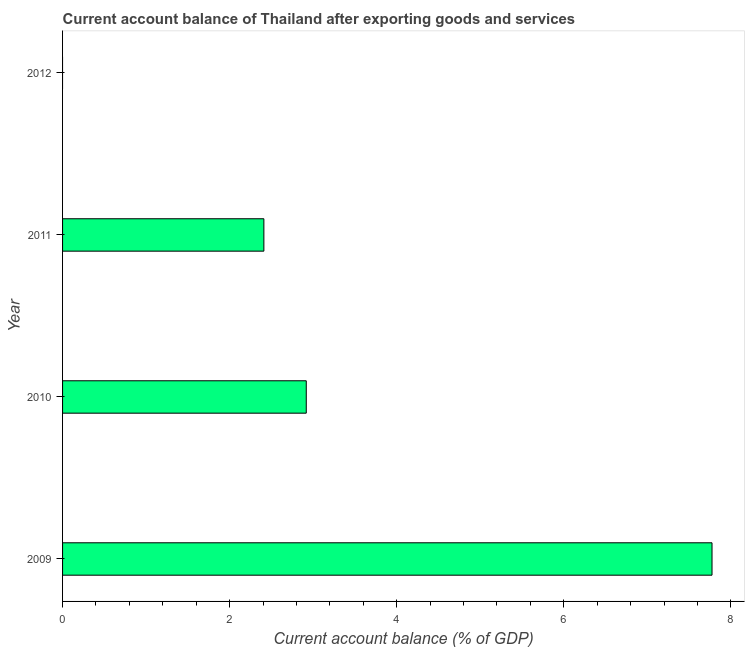Does the graph contain any zero values?
Offer a very short reply. Yes. Does the graph contain grids?
Give a very brief answer. No. What is the title of the graph?
Give a very brief answer. Current account balance of Thailand after exporting goods and services. What is the label or title of the X-axis?
Give a very brief answer. Current account balance (% of GDP). What is the label or title of the Y-axis?
Your answer should be very brief. Year. What is the current account balance in 2010?
Offer a very short reply. 2.92. Across all years, what is the maximum current account balance?
Provide a succinct answer. 7.77. Across all years, what is the minimum current account balance?
Offer a very short reply. 0. In which year was the current account balance maximum?
Make the answer very short. 2009. What is the sum of the current account balance?
Keep it short and to the point. 13.1. What is the difference between the current account balance in 2009 and 2011?
Your response must be concise. 5.37. What is the average current account balance per year?
Make the answer very short. 3.27. What is the median current account balance?
Give a very brief answer. 2.66. What is the ratio of the current account balance in 2009 to that in 2011?
Offer a terse response. 3.23. Is the current account balance in 2009 less than that in 2010?
Provide a succinct answer. No. Is the difference between the current account balance in 2009 and 2011 greater than the difference between any two years?
Your answer should be compact. No. What is the difference between the highest and the second highest current account balance?
Make the answer very short. 4.86. Is the sum of the current account balance in 2009 and 2010 greater than the maximum current account balance across all years?
Your answer should be compact. Yes. What is the difference between the highest and the lowest current account balance?
Offer a very short reply. 7.77. In how many years, is the current account balance greater than the average current account balance taken over all years?
Provide a short and direct response. 1. How many bars are there?
Give a very brief answer. 3. Are all the bars in the graph horizontal?
Ensure brevity in your answer.  Yes. How many years are there in the graph?
Keep it short and to the point. 4. Are the values on the major ticks of X-axis written in scientific E-notation?
Keep it short and to the point. No. What is the Current account balance (% of GDP) of 2009?
Your answer should be compact. 7.77. What is the Current account balance (% of GDP) of 2010?
Provide a succinct answer. 2.92. What is the Current account balance (% of GDP) of 2011?
Give a very brief answer. 2.41. What is the Current account balance (% of GDP) in 2012?
Give a very brief answer. 0. What is the difference between the Current account balance (% of GDP) in 2009 and 2010?
Offer a very short reply. 4.86. What is the difference between the Current account balance (% of GDP) in 2009 and 2011?
Offer a very short reply. 5.36. What is the difference between the Current account balance (% of GDP) in 2010 and 2011?
Ensure brevity in your answer.  0.51. What is the ratio of the Current account balance (% of GDP) in 2009 to that in 2010?
Your answer should be very brief. 2.67. What is the ratio of the Current account balance (% of GDP) in 2009 to that in 2011?
Your answer should be compact. 3.23. What is the ratio of the Current account balance (% of GDP) in 2010 to that in 2011?
Offer a very short reply. 1.21. 